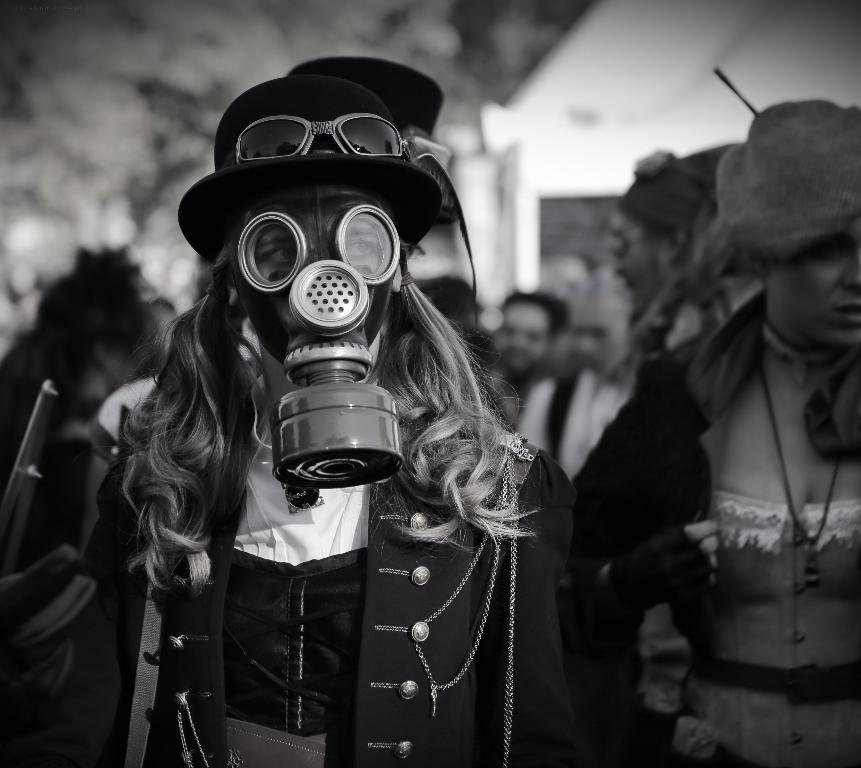What is happening in the image? There are people standing in the image. Can you describe the attire of one of the people? A person in the front is wearing a mask. What is the quality of the background in the image? The background of the image is blurry. Can you see any trees in the image? There is no mention of trees in the provided facts, so we cannot determine if they are present in the image. 